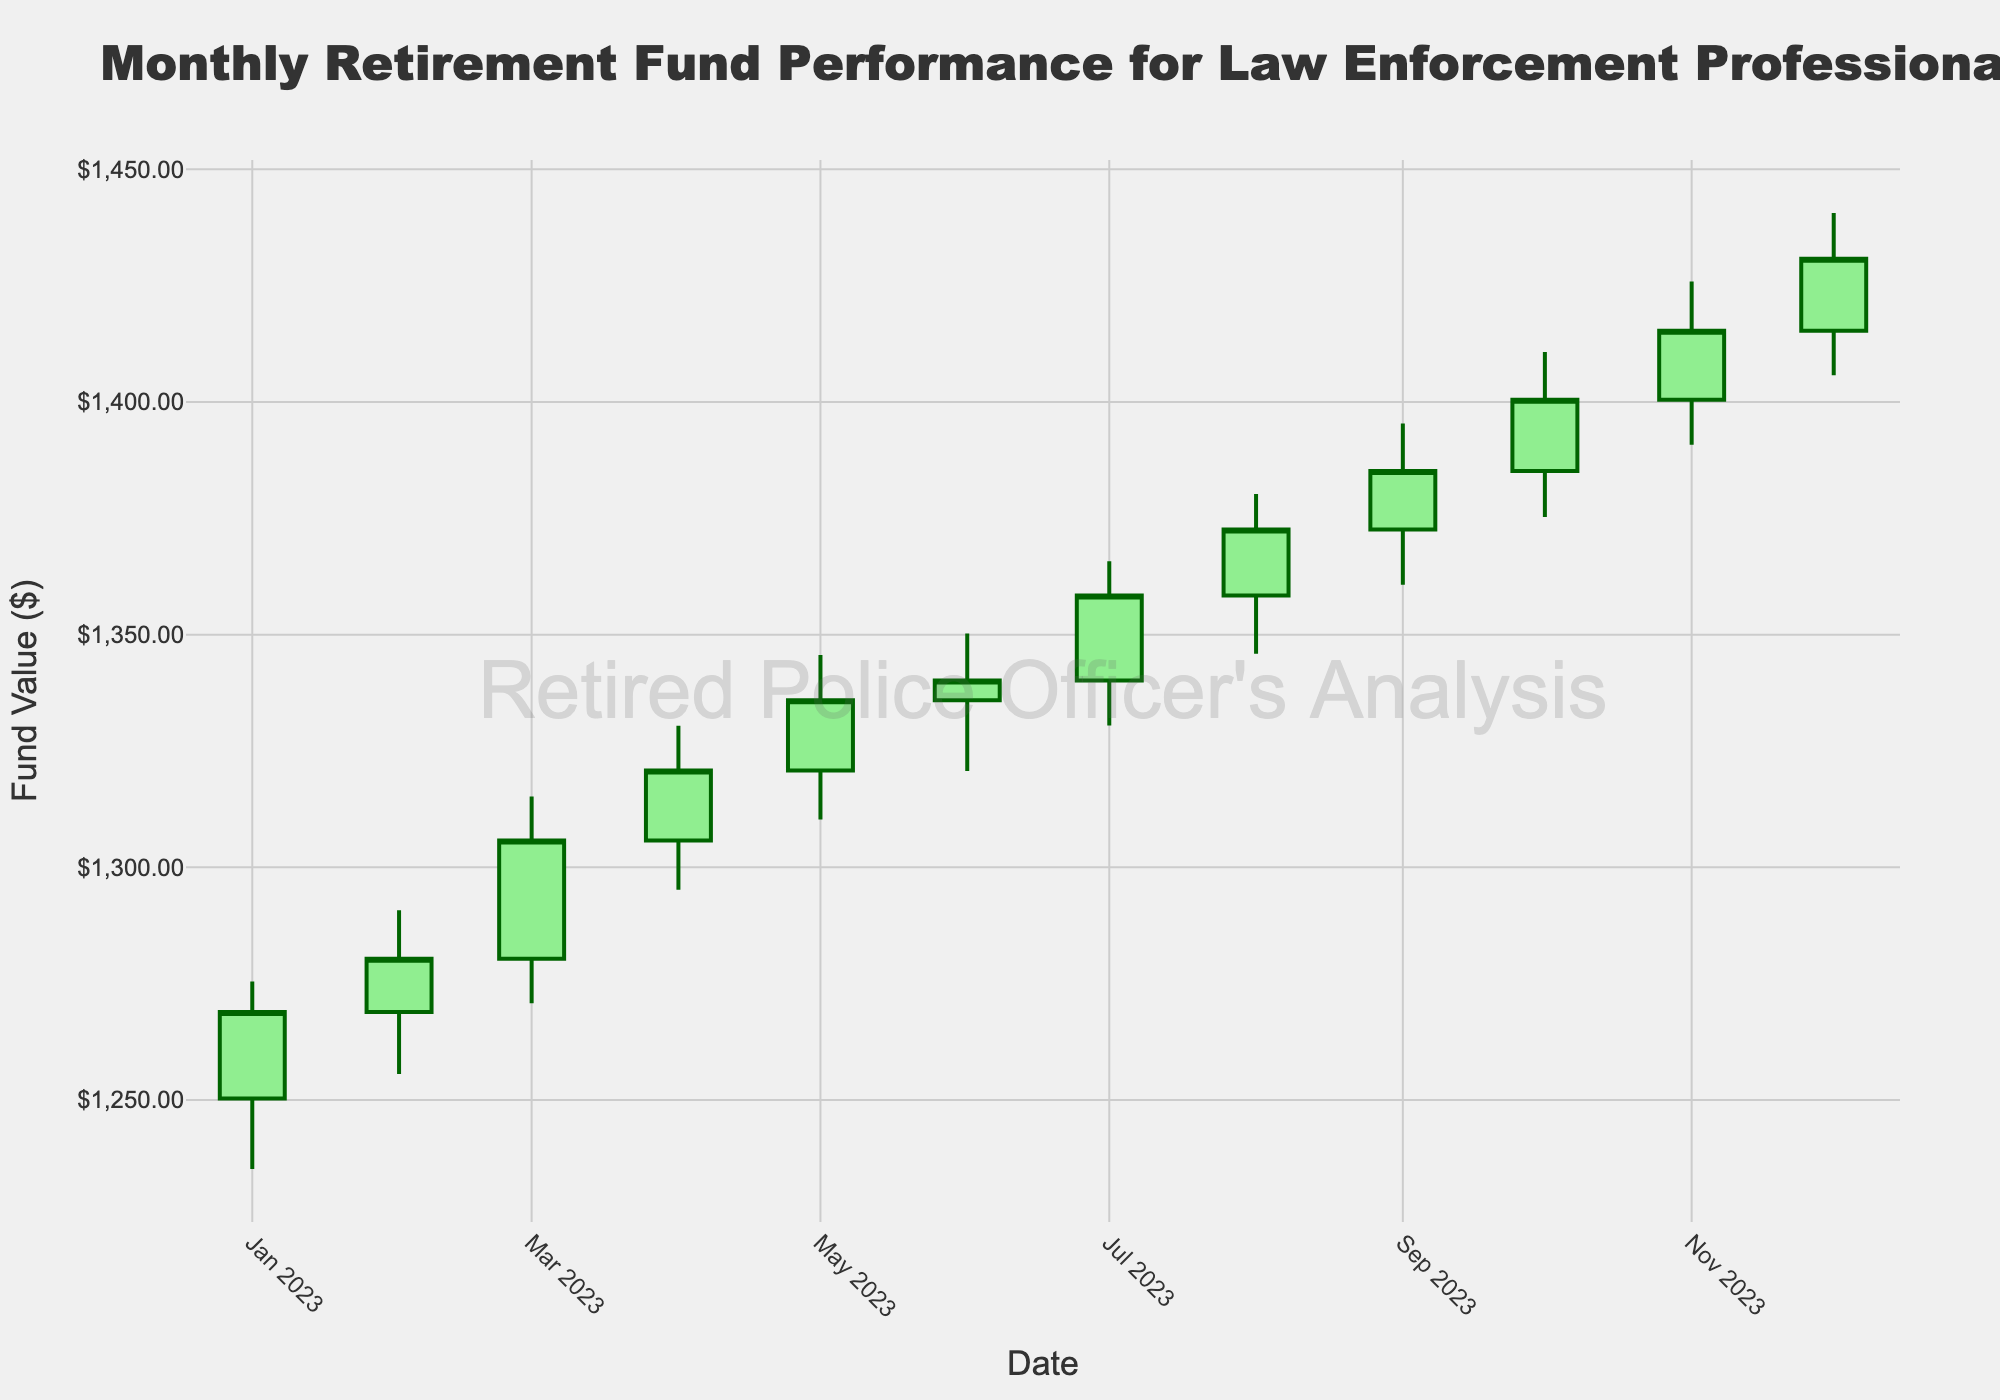what’s the title of the figure? The title is prominently displayed at the top of the figure.
Answer: Monthly Retirement Fund Performance for Law Enforcement Professionals Which two months have the highest closing values? To determine this, look for the months with the highest "Close" values. The highest closing values are 1430.80 in December and 1415.30 in November.
Answer: November and December What’s the lowest value observed in any month? The lowest value can be found by observing the "Low" values and picking the lowest one. In this case, the lowest value is 1235.18 in January.
Answer: 1235.18 Which month shows the greatest increase from opening to closing value? Calculate the difference between the "Open" and "Close" for each month and find the maximum. September (1385.20 - 1372.60 = 12.60) shows the greatest increase.
Answer: September Which month has the highest high value? Look at the "High" values and identify the highest one. The highest value is 1440.60 in December.
Answer: December How many months have a closing value higher than their opening value? Compare the "Close" and "Open" values for each month and count the occurrences where "Close" > "Open". This condition is met in all 12 months.
Answer: 12 What’s the average closing value for the entire year? Sum all "Close" values and divide by the number of months. (1268.90 + 1280.35 + 1305.75 + 1320.80 + 1335.90 + 1340.15 + 1358.40 + 1372.60 + 1385.20 + 1400.50 + 1415.30 + 1430.80) / 12 = 1343.12
Answer: 1343.13 Which month shows the greatest range between its high and low values? Subtract the "Low" value from the "High" value for each month and find the maximum difference. December (1440.60 - 1405.75 = 34.85) shows the greatest range.
Answer: December 